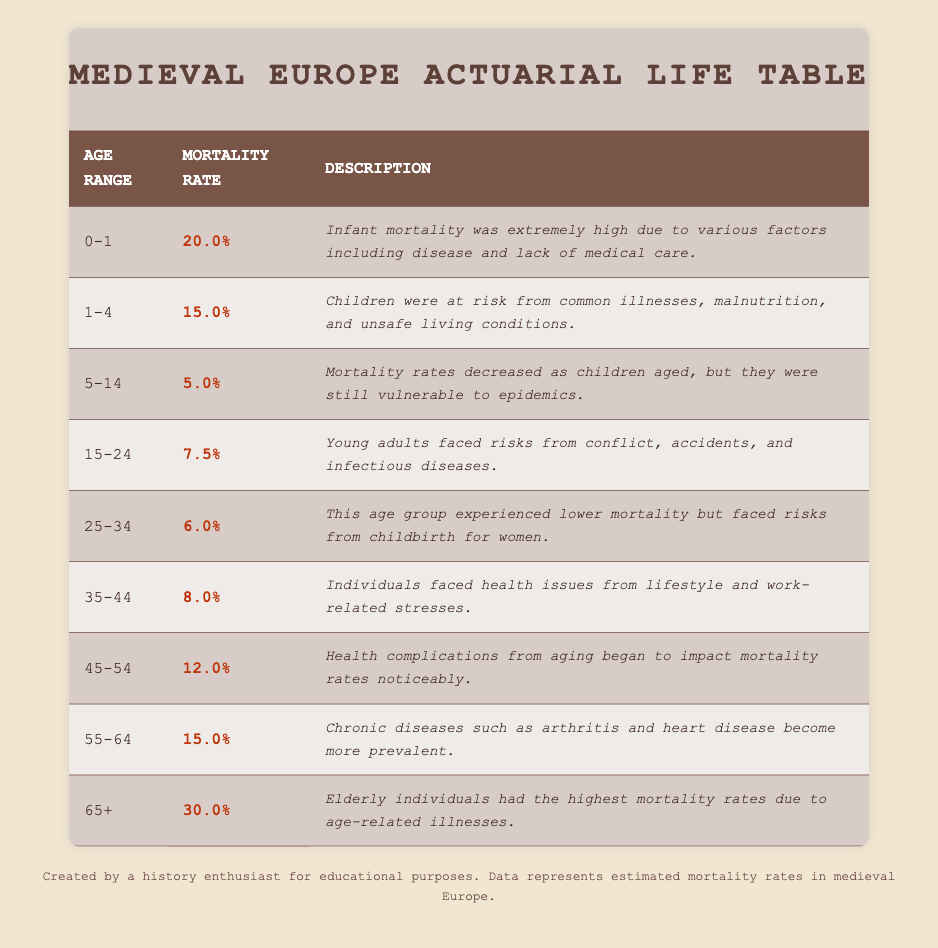What is the mortality rate for infants aged 0-1? The table states that the mortality rate for the age group 0-1 is 20.0%.
Answer: 20.0% Which age group has the highest mortality rate? According to the table, the age group 65+ has the highest mortality rate at 30.0%.
Answer: 65+ What is the mortality rate for children aged 5-14? The table indicates that the mortality rate for the age group 5-14 is 5.0%.
Answer: 5.0% Is the mortality rate for those aged 15-24 higher than those aged 25-34? Yes, the mortality rate for the age group 15-24 is 7.5% while for 25-34, it is 6.0%.
Answer: Yes What is the average mortality rate for ages 0-14? To find the average, sum the mortality rates for ages 0-1 (20.0%), 1-4 (15.0%), and 5-14 (5.0%), which is 20.0 + 15.0 + 5.0 = 40.0%. Divide by 3 to get an average of 13.33%.
Answer: 13.33% What is the difference in mortality rates between age groups 55-64 and 65+? The mortality rate for 55-64 is 15.0%, and for 65+, it is 30.0%. The difference is 30.0% - 15.0% = 15.0%.
Answer: 15.0% Are health complications from aging impacting individuals aged 45-54? Yes, the table states that individuals in this age group begin to face noticeable impacts from health complications due to aging, indicated by a mortality rate of 12.0%.
Answer: Yes Which age range experiences lower mortality rates, 25-34 or 35-44? The age group 25-34 has a mortality rate of 6.0%, whereas 35-44 has a rate of 8.0%. Thus, 25-34 experiences lower mortality rates.
Answer: 25-34 What percentage of young adults aged 15-24 are likely to die due to infectious diseases? The mortality rate for young adults aged 15-24 is 7.5%, which indicates the likelihood of dying from infectious diseases as per the description.
Answer: 7.5% 